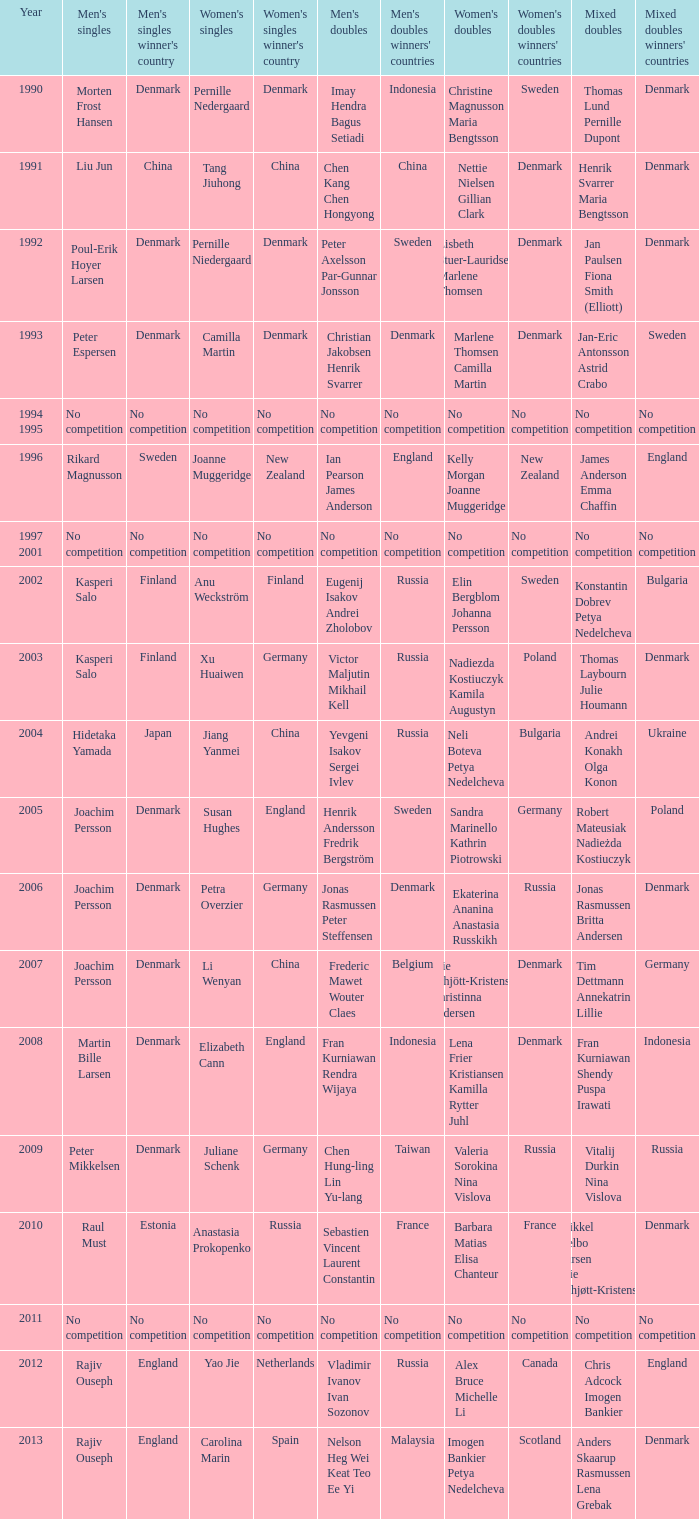What year did Carolina Marin win the Women's singles? 2013.0. 